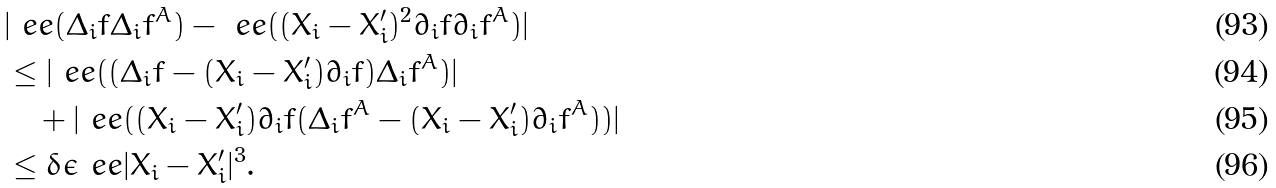<formula> <loc_0><loc_0><loc_500><loc_500>& | \ e e ( \Delta _ { i } f \Delta _ { i } f ^ { A } ) - \ e e ( ( X _ { i } - X _ { i } ^ { \prime } ) ^ { 2 } \partial _ { i } f \partial _ { i } f ^ { A } ) | \\ & \leq | \ e e ( ( \Delta _ { i } f - ( X _ { i } - X _ { i } ^ { \prime } ) \partial _ { i } f ) \Delta _ { i } f ^ { A } ) | \\ & \quad + | \ e e ( ( X _ { i } - X _ { i } ^ { \prime } ) \partial _ { i } f ( \Delta _ { i } f ^ { A } - ( X _ { i } - X _ { i } ^ { \prime } ) \partial _ { i } f ^ { A } ) ) | \\ & \leq \delta \epsilon \ e e | X _ { i } - X _ { i } ^ { \prime } | ^ { 3 } .</formula> 